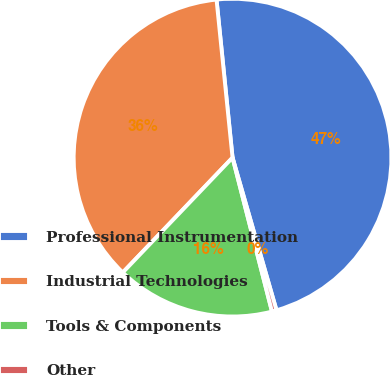Convert chart. <chart><loc_0><loc_0><loc_500><loc_500><pie_chart><fcel>Professional Instrumentation<fcel>Industrial Technologies<fcel>Tools & Components<fcel>Other<nl><fcel>47.14%<fcel>36.25%<fcel>16.13%<fcel>0.47%<nl></chart> 